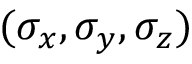<formula> <loc_0><loc_0><loc_500><loc_500>( \sigma _ { x } , \sigma _ { y } , \sigma _ { z } )</formula> 